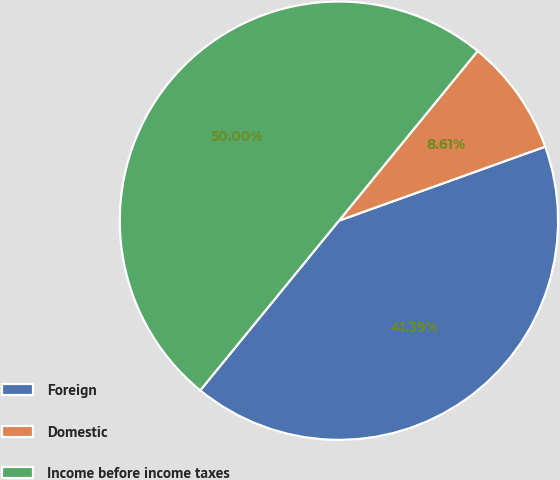Convert chart. <chart><loc_0><loc_0><loc_500><loc_500><pie_chart><fcel>Foreign<fcel>Domestic<fcel>Income before income taxes<nl><fcel>41.39%<fcel>8.61%<fcel>50.0%<nl></chart> 